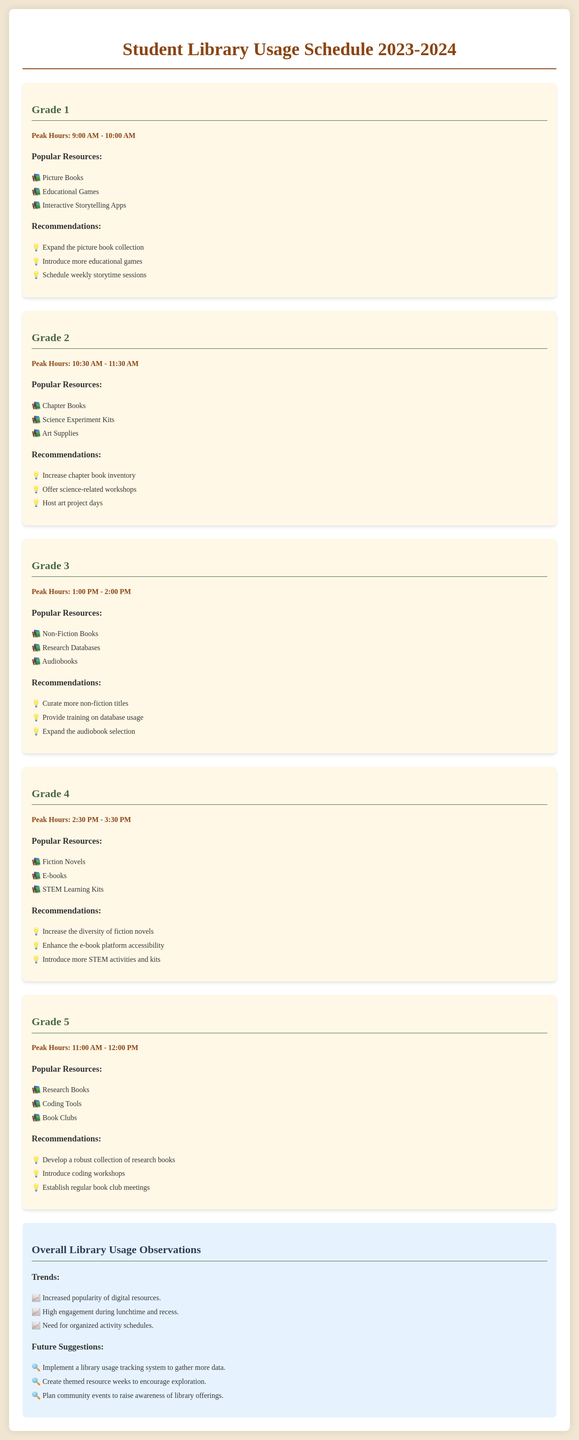What are the peak hours for Grade 1? The peak hours are specified in the document section for Grade 1, which is from 9:00 AM to 10:00 AM.
Answer: 9:00 AM - 10:00 AM What popular resources are mentioned for Grade 3? The popular resources listed for Grade 3 can be found in its dedicated section in the document.
Answer: Non-Fiction Books, Research Databases, Audiobooks What recommendations are provided for Grade 4? The recommendations for Grade 4 are detailed in that section and include various suggestions.
Answer: Increase the diversity of fiction novels, Enhance the e-book platform accessibility, Introduce more STEM activities and kits What is the peak hour for Grade 5? The peak hour for Grade 5 is mentioned in the corresponding section of the document.
Answer: 11:00 AM - 12:00 PM What trend is noted regarding library usage? The trends are summarized in the overall observations section, highlighting key observations.
Answer: Increased popularity of digital resources Which grade has peak hours from 10:30 AM to 11:30 AM? The peak hours for that specific time are provided in the document and must be identified accordingly.
Answer: Grade 2 What suggestion is made for future library events? Future suggestions are found in the document's overall observations, pinpointing areas for improvement.
Answer: Plan community events to raise awareness of library offerings Which popular resource is listed for Grade 2? Popular resources for Grade 2 are outlined, providing insight into the resources favored by students in that grade.
Answer: Chapter Books What are the peak hours for Grade 4? The document specifies the peak hours for Grade 4 clearly under its dedicated section.
Answer: 2:30 PM - 3:30 PM What kind of database are Grade 3 students using? The resources available for Grade 3 include the types of databases that students can access.
Answer: Research Databases 